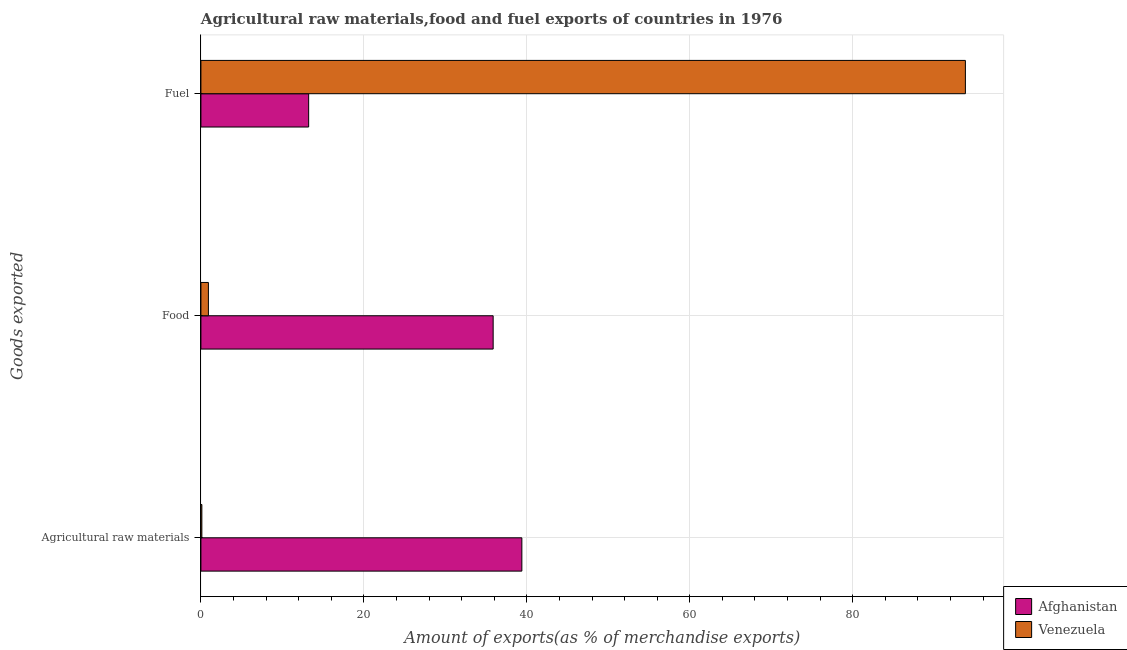How many different coloured bars are there?
Ensure brevity in your answer.  2. Are the number of bars per tick equal to the number of legend labels?
Make the answer very short. Yes. How many bars are there on the 2nd tick from the top?
Make the answer very short. 2. How many bars are there on the 3rd tick from the bottom?
Ensure brevity in your answer.  2. What is the label of the 1st group of bars from the top?
Give a very brief answer. Fuel. What is the percentage of raw materials exports in Afghanistan?
Your answer should be compact. 39.39. Across all countries, what is the maximum percentage of food exports?
Offer a terse response. 35.87. Across all countries, what is the minimum percentage of raw materials exports?
Your answer should be very brief. 0.12. In which country was the percentage of fuel exports maximum?
Make the answer very short. Venezuela. In which country was the percentage of fuel exports minimum?
Provide a short and direct response. Afghanistan. What is the total percentage of fuel exports in the graph?
Your answer should be compact. 107.05. What is the difference between the percentage of raw materials exports in Afghanistan and that in Venezuela?
Provide a short and direct response. 39.27. What is the difference between the percentage of fuel exports in Afghanistan and the percentage of food exports in Venezuela?
Your answer should be compact. 12.3. What is the average percentage of food exports per country?
Your response must be concise. 18.39. What is the difference between the percentage of fuel exports and percentage of raw materials exports in Venezuela?
Keep it short and to the point. 93.71. What is the ratio of the percentage of raw materials exports in Afghanistan to that in Venezuela?
Your response must be concise. 340.08. Is the difference between the percentage of raw materials exports in Venezuela and Afghanistan greater than the difference between the percentage of food exports in Venezuela and Afghanistan?
Offer a very short reply. No. What is the difference between the highest and the second highest percentage of fuel exports?
Your answer should be compact. 80.6. What is the difference between the highest and the lowest percentage of food exports?
Your answer should be very brief. 34.95. In how many countries, is the percentage of food exports greater than the average percentage of food exports taken over all countries?
Ensure brevity in your answer.  1. Is the sum of the percentage of fuel exports in Venezuela and Afghanistan greater than the maximum percentage of food exports across all countries?
Provide a succinct answer. Yes. What does the 2nd bar from the top in Fuel represents?
Offer a terse response. Afghanistan. What does the 1st bar from the bottom in Fuel represents?
Your answer should be very brief. Afghanistan. Is it the case that in every country, the sum of the percentage of raw materials exports and percentage of food exports is greater than the percentage of fuel exports?
Offer a terse response. No. How many bars are there?
Give a very brief answer. 6. How many countries are there in the graph?
Your answer should be very brief. 2. Does the graph contain any zero values?
Offer a very short reply. No. Does the graph contain grids?
Provide a short and direct response. Yes. Where does the legend appear in the graph?
Ensure brevity in your answer.  Bottom right. How many legend labels are there?
Offer a terse response. 2. What is the title of the graph?
Provide a succinct answer. Agricultural raw materials,food and fuel exports of countries in 1976. What is the label or title of the X-axis?
Ensure brevity in your answer.  Amount of exports(as % of merchandise exports). What is the label or title of the Y-axis?
Your answer should be compact. Goods exported. What is the Amount of exports(as % of merchandise exports) of Afghanistan in Agricultural raw materials?
Offer a terse response. 39.39. What is the Amount of exports(as % of merchandise exports) of Venezuela in Agricultural raw materials?
Ensure brevity in your answer.  0.12. What is the Amount of exports(as % of merchandise exports) of Afghanistan in Food?
Provide a short and direct response. 35.87. What is the Amount of exports(as % of merchandise exports) of Venezuela in Food?
Offer a very short reply. 0.92. What is the Amount of exports(as % of merchandise exports) of Afghanistan in Fuel?
Give a very brief answer. 13.22. What is the Amount of exports(as % of merchandise exports) in Venezuela in Fuel?
Your answer should be compact. 93.83. Across all Goods exported, what is the maximum Amount of exports(as % of merchandise exports) in Afghanistan?
Your answer should be very brief. 39.39. Across all Goods exported, what is the maximum Amount of exports(as % of merchandise exports) of Venezuela?
Your answer should be very brief. 93.83. Across all Goods exported, what is the minimum Amount of exports(as % of merchandise exports) in Afghanistan?
Provide a short and direct response. 13.22. Across all Goods exported, what is the minimum Amount of exports(as % of merchandise exports) in Venezuela?
Your answer should be very brief. 0.12. What is the total Amount of exports(as % of merchandise exports) in Afghanistan in the graph?
Provide a short and direct response. 88.48. What is the total Amount of exports(as % of merchandise exports) of Venezuela in the graph?
Make the answer very short. 94.86. What is the difference between the Amount of exports(as % of merchandise exports) in Afghanistan in Agricultural raw materials and that in Food?
Offer a very short reply. 3.52. What is the difference between the Amount of exports(as % of merchandise exports) of Venezuela in Agricultural raw materials and that in Food?
Your answer should be compact. -0.8. What is the difference between the Amount of exports(as % of merchandise exports) of Afghanistan in Agricultural raw materials and that in Fuel?
Provide a short and direct response. 26.17. What is the difference between the Amount of exports(as % of merchandise exports) of Venezuela in Agricultural raw materials and that in Fuel?
Your answer should be compact. -93.71. What is the difference between the Amount of exports(as % of merchandise exports) of Afghanistan in Food and that in Fuel?
Offer a very short reply. 22.64. What is the difference between the Amount of exports(as % of merchandise exports) of Venezuela in Food and that in Fuel?
Provide a short and direct response. -92.91. What is the difference between the Amount of exports(as % of merchandise exports) of Afghanistan in Agricultural raw materials and the Amount of exports(as % of merchandise exports) of Venezuela in Food?
Offer a very short reply. 38.47. What is the difference between the Amount of exports(as % of merchandise exports) in Afghanistan in Agricultural raw materials and the Amount of exports(as % of merchandise exports) in Venezuela in Fuel?
Make the answer very short. -54.44. What is the difference between the Amount of exports(as % of merchandise exports) in Afghanistan in Food and the Amount of exports(as % of merchandise exports) in Venezuela in Fuel?
Make the answer very short. -57.96. What is the average Amount of exports(as % of merchandise exports) of Afghanistan per Goods exported?
Keep it short and to the point. 29.49. What is the average Amount of exports(as % of merchandise exports) of Venezuela per Goods exported?
Keep it short and to the point. 31.62. What is the difference between the Amount of exports(as % of merchandise exports) in Afghanistan and Amount of exports(as % of merchandise exports) in Venezuela in Agricultural raw materials?
Your answer should be compact. 39.27. What is the difference between the Amount of exports(as % of merchandise exports) of Afghanistan and Amount of exports(as % of merchandise exports) of Venezuela in Food?
Offer a terse response. 34.95. What is the difference between the Amount of exports(as % of merchandise exports) of Afghanistan and Amount of exports(as % of merchandise exports) of Venezuela in Fuel?
Give a very brief answer. -80.6. What is the ratio of the Amount of exports(as % of merchandise exports) in Afghanistan in Agricultural raw materials to that in Food?
Your response must be concise. 1.1. What is the ratio of the Amount of exports(as % of merchandise exports) of Venezuela in Agricultural raw materials to that in Food?
Give a very brief answer. 0.13. What is the ratio of the Amount of exports(as % of merchandise exports) of Afghanistan in Agricultural raw materials to that in Fuel?
Your response must be concise. 2.98. What is the ratio of the Amount of exports(as % of merchandise exports) of Venezuela in Agricultural raw materials to that in Fuel?
Your answer should be compact. 0. What is the ratio of the Amount of exports(as % of merchandise exports) in Afghanistan in Food to that in Fuel?
Your response must be concise. 2.71. What is the ratio of the Amount of exports(as % of merchandise exports) of Venezuela in Food to that in Fuel?
Give a very brief answer. 0.01. What is the difference between the highest and the second highest Amount of exports(as % of merchandise exports) of Afghanistan?
Provide a succinct answer. 3.52. What is the difference between the highest and the second highest Amount of exports(as % of merchandise exports) of Venezuela?
Provide a short and direct response. 92.91. What is the difference between the highest and the lowest Amount of exports(as % of merchandise exports) of Afghanistan?
Provide a short and direct response. 26.17. What is the difference between the highest and the lowest Amount of exports(as % of merchandise exports) of Venezuela?
Ensure brevity in your answer.  93.71. 